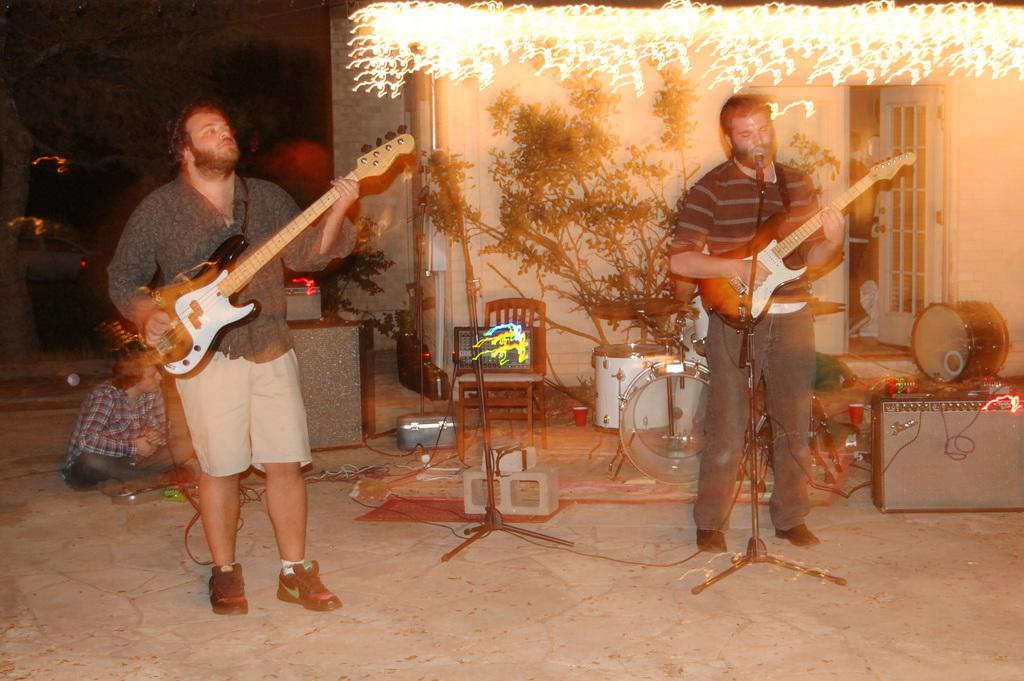How many people are in the image? There are two persons in the image. What are the persons doing in the image? The persons are playing musical instruments. What can be seen in the background of the image? There is a plant and lights in the background of the image. Can you see any bones in the image? There are no bones visible in the image. Are there any bees buzzing around the persons in the image? There is no mention of bees in the image, and they are not visible. 